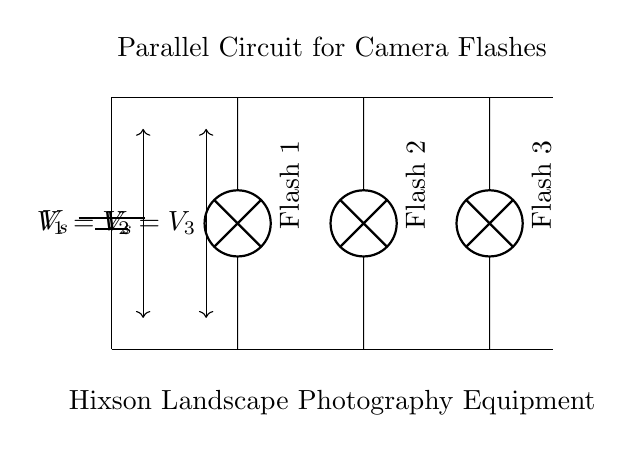What is the type of this circuit? The circuit is a parallel circuit, which is characterized by its multiple branches that can operate independently of each other. Here, the camera flashes are connected in parallel, allowing each to receive the same voltage from the power source.
Answer: Parallel circuit How many camera flashes are connected? There are three camera flashes shown in the diagram, indicated by the three lamp symbols in the lower section of the circuit, which are connected in parallel.
Answer: Three What is the voltage across each flash? The voltage across each flash is equal to the voltage of the power source, which is denoted by V_s. In a parallel circuit, each component experiences the same voltage.
Answer: V_s Does the current through each flash remain the same? No, the current through each flash can differ, depending on their individual resistances. In a parallel circuit, the total current is the sum of the currents through each branch, but each flash can draw different amounts of current based on its own characteristics.
Answer: No What is the advantage of using a parallel circuit for flashes? The advantage is that each flash can operate independently; if one flash fails, the others will still function properly. This ensures reliable lighting for photography, particularly in outdoor settings.
Answer: Reliability What is the total current drawn from the battery? The total current drawn from the battery is the sum of the individual currents through each flash, which can be calculated if the resistance of each flash is known. However, the circuit diagram does not provide resistance values or current information, so a numerical answer isn't possible.
Answer: Not determinable 